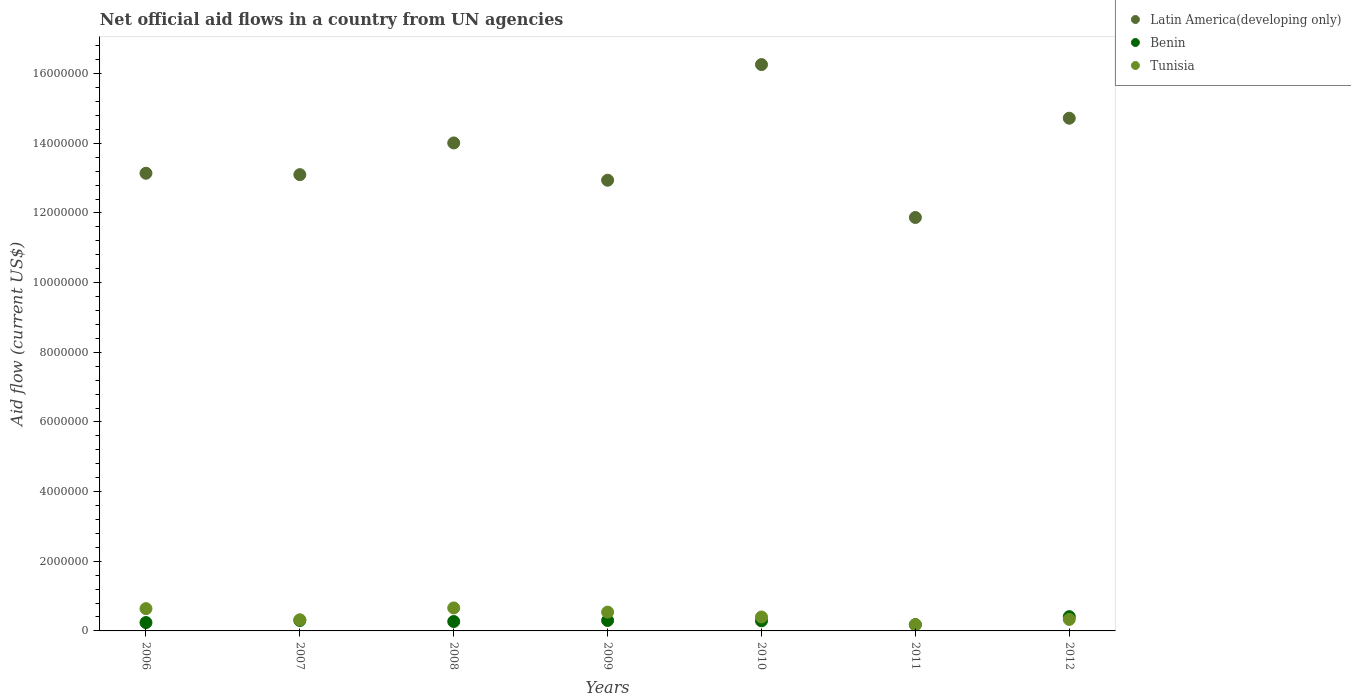Is the number of dotlines equal to the number of legend labels?
Ensure brevity in your answer.  Yes. What is the net official aid flow in Tunisia in 2008?
Ensure brevity in your answer.  6.60e+05. Across all years, what is the maximum net official aid flow in Benin?
Offer a very short reply. 4.10e+05. Across all years, what is the minimum net official aid flow in Tunisia?
Your answer should be very brief. 1.80e+05. In which year was the net official aid flow in Tunisia minimum?
Give a very brief answer. 2011. What is the total net official aid flow in Tunisia in the graph?
Your response must be concise. 3.07e+06. What is the difference between the net official aid flow in Tunisia in 2008 and that in 2010?
Make the answer very short. 2.60e+05. What is the difference between the net official aid flow in Latin America(developing only) in 2009 and the net official aid flow in Benin in 2008?
Ensure brevity in your answer.  1.27e+07. What is the average net official aid flow in Latin America(developing only) per year?
Your response must be concise. 1.37e+07. In the year 2006, what is the difference between the net official aid flow in Latin America(developing only) and net official aid flow in Tunisia?
Provide a short and direct response. 1.25e+07. What is the ratio of the net official aid flow in Benin in 2010 to that in 2012?
Your answer should be very brief. 0.71. Is the net official aid flow in Latin America(developing only) in 2006 less than that in 2007?
Your answer should be compact. No. What is the difference between the highest and the second highest net official aid flow in Latin America(developing only)?
Make the answer very short. 1.54e+06. What is the difference between the highest and the lowest net official aid flow in Benin?
Provide a short and direct response. 2.30e+05. Is it the case that in every year, the sum of the net official aid flow in Latin America(developing only) and net official aid flow in Tunisia  is greater than the net official aid flow in Benin?
Provide a short and direct response. Yes. Does the net official aid flow in Latin America(developing only) monotonically increase over the years?
Make the answer very short. No. How many years are there in the graph?
Your answer should be very brief. 7. Are the values on the major ticks of Y-axis written in scientific E-notation?
Make the answer very short. No. Does the graph contain any zero values?
Provide a succinct answer. No. Does the graph contain grids?
Ensure brevity in your answer.  No. Where does the legend appear in the graph?
Provide a succinct answer. Top right. How many legend labels are there?
Provide a short and direct response. 3. How are the legend labels stacked?
Your answer should be compact. Vertical. What is the title of the graph?
Ensure brevity in your answer.  Net official aid flows in a country from UN agencies. Does "Upper middle income" appear as one of the legend labels in the graph?
Give a very brief answer. No. What is the Aid flow (current US$) of Latin America(developing only) in 2006?
Keep it short and to the point. 1.31e+07. What is the Aid flow (current US$) of Tunisia in 2006?
Offer a very short reply. 6.40e+05. What is the Aid flow (current US$) of Latin America(developing only) in 2007?
Keep it short and to the point. 1.31e+07. What is the Aid flow (current US$) of Latin America(developing only) in 2008?
Make the answer very short. 1.40e+07. What is the Aid flow (current US$) of Latin America(developing only) in 2009?
Keep it short and to the point. 1.29e+07. What is the Aid flow (current US$) of Tunisia in 2009?
Your response must be concise. 5.40e+05. What is the Aid flow (current US$) of Latin America(developing only) in 2010?
Your response must be concise. 1.63e+07. What is the Aid flow (current US$) of Latin America(developing only) in 2011?
Give a very brief answer. 1.19e+07. What is the Aid flow (current US$) of Benin in 2011?
Keep it short and to the point. 1.80e+05. What is the Aid flow (current US$) in Tunisia in 2011?
Keep it short and to the point. 1.80e+05. What is the Aid flow (current US$) in Latin America(developing only) in 2012?
Ensure brevity in your answer.  1.47e+07. Across all years, what is the maximum Aid flow (current US$) in Latin America(developing only)?
Provide a short and direct response. 1.63e+07. Across all years, what is the maximum Aid flow (current US$) in Tunisia?
Provide a succinct answer. 6.60e+05. Across all years, what is the minimum Aid flow (current US$) of Latin America(developing only)?
Your answer should be compact. 1.19e+07. What is the total Aid flow (current US$) of Latin America(developing only) in the graph?
Your response must be concise. 9.60e+07. What is the total Aid flow (current US$) in Benin in the graph?
Your answer should be compact. 1.99e+06. What is the total Aid flow (current US$) of Tunisia in the graph?
Give a very brief answer. 3.07e+06. What is the difference between the Aid flow (current US$) in Latin America(developing only) in 2006 and that in 2007?
Your answer should be compact. 4.00e+04. What is the difference between the Aid flow (current US$) in Benin in 2006 and that in 2007?
Your answer should be very brief. -6.00e+04. What is the difference between the Aid flow (current US$) of Tunisia in 2006 and that in 2007?
Ensure brevity in your answer.  3.20e+05. What is the difference between the Aid flow (current US$) in Latin America(developing only) in 2006 and that in 2008?
Your answer should be compact. -8.70e+05. What is the difference between the Aid flow (current US$) of Benin in 2006 and that in 2008?
Your response must be concise. -3.00e+04. What is the difference between the Aid flow (current US$) in Tunisia in 2006 and that in 2008?
Give a very brief answer. -2.00e+04. What is the difference between the Aid flow (current US$) in Latin America(developing only) in 2006 and that in 2009?
Give a very brief answer. 2.00e+05. What is the difference between the Aid flow (current US$) in Tunisia in 2006 and that in 2009?
Offer a terse response. 1.00e+05. What is the difference between the Aid flow (current US$) in Latin America(developing only) in 2006 and that in 2010?
Offer a very short reply. -3.12e+06. What is the difference between the Aid flow (current US$) of Tunisia in 2006 and that in 2010?
Your response must be concise. 2.40e+05. What is the difference between the Aid flow (current US$) of Latin America(developing only) in 2006 and that in 2011?
Offer a terse response. 1.27e+06. What is the difference between the Aid flow (current US$) in Benin in 2006 and that in 2011?
Give a very brief answer. 6.00e+04. What is the difference between the Aid flow (current US$) in Tunisia in 2006 and that in 2011?
Your response must be concise. 4.60e+05. What is the difference between the Aid flow (current US$) in Latin America(developing only) in 2006 and that in 2012?
Provide a succinct answer. -1.58e+06. What is the difference between the Aid flow (current US$) of Tunisia in 2006 and that in 2012?
Ensure brevity in your answer.  3.10e+05. What is the difference between the Aid flow (current US$) of Latin America(developing only) in 2007 and that in 2008?
Your response must be concise. -9.10e+05. What is the difference between the Aid flow (current US$) of Benin in 2007 and that in 2008?
Make the answer very short. 3.00e+04. What is the difference between the Aid flow (current US$) in Tunisia in 2007 and that in 2008?
Provide a short and direct response. -3.40e+05. What is the difference between the Aid flow (current US$) of Benin in 2007 and that in 2009?
Your response must be concise. 0. What is the difference between the Aid flow (current US$) of Latin America(developing only) in 2007 and that in 2010?
Provide a succinct answer. -3.16e+06. What is the difference between the Aid flow (current US$) in Benin in 2007 and that in 2010?
Keep it short and to the point. 10000. What is the difference between the Aid flow (current US$) in Tunisia in 2007 and that in 2010?
Your answer should be compact. -8.00e+04. What is the difference between the Aid flow (current US$) of Latin America(developing only) in 2007 and that in 2011?
Your answer should be compact. 1.23e+06. What is the difference between the Aid flow (current US$) of Benin in 2007 and that in 2011?
Your response must be concise. 1.20e+05. What is the difference between the Aid flow (current US$) in Latin America(developing only) in 2007 and that in 2012?
Offer a terse response. -1.62e+06. What is the difference between the Aid flow (current US$) of Benin in 2007 and that in 2012?
Your answer should be compact. -1.10e+05. What is the difference between the Aid flow (current US$) in Tunisia in 2007 and that in 2012?
Offer a very short reply. -10000. What is the difference between the Aid flow (current US$) of Latin America(developing only) in 2008 and that in 2009?
Ensure brevity in your answer.  1.07e+06. What is the difference between the Aid flow (current US$) in Benin in 2008 and that in 2009?
Provide a short and direct response. -3.00e+04. What is the difference between the Aid flow (current US$) of Latin America(developing only) in 2008 and that in 2010?
Your answer should be compact. -2.25e+06. What is the difference between the Aid flow (current US$) of Benin in 2008 and that in 2010?
Your answer should be compact. -2.00e+04. What is the difference between the Aid flow (current US$) in Tunisia in 2008 and that in 2010?
Offer a terse response. 2.60e+05. What is the difference between the Aid flow (current US$) in Latin America(developing only) in 2008 and that in 2011?
Your answer should be compact. 2.14e+06. What is the difference between the Aid flow (current US$) of Benin in 2008 and that in 2011?
Offer a terse response. 9.00e+04. What is the difference between the Aid flow (current US$) in Latin America(developing only) in 2008 and that in 2012?
Your answer should be compact. -7.10e+05. What is the difference between the Aid flow (current US$) of Tunisia in 2008 and that in 2012?
Your answer should be compact. 3.30e+05. What is the difference between the Aid flow (current US$) of Latin America(developing only) in 2009 and that in 2010?
Offer a very short reply. -3.32e+06. What is the difference between the Aid flow (current US$) of Latin America(developing only) in 2009 and that in 2011?
Ensure brevity in your answer.  1.07e+06. What is the difference between the Aid flow (current US$) of Benin in 2009 and that in 2011?
Ensure brevity in your answer.  1.20e+05. What is the difference between the Aid flow (current US$) of Latin America(developing only) in 2009 and that in 2012?
Your answer should be compact. -1.78e+06. What is the difference between the Aid flow (current US$) of Tunisia in 2009 and that in 2012?
Your response must be concise. 2.10e+05. What is the difference between the Aid flow (current US$) in Latin America(developing only) in 2010 and that in 2011?
Offer a very short reply. 4.39e+06. What is the difference between the Aid flow (current US$) in Benin in 2010 and that in 2011?
Provide a succinct answer. 1.10e+05. What is the difference between the Aid flow (current US$) of Latin America(developing only) in 2010 and that in 2012?
Offer a very short reply. 1.54e+06. What is the difference between the Aid flow (current US$) of Latin America(developing only) in 2011 and that in 2012?
Give a very brief answer. -2.85e+06. What is the difference between the Aid flow (current US$) in Benin in 2011 and that in 2012?
Give a very brief answer. -2.30e+05. What is the difference between the Aid flow (current US$) of Tunisia in 2011 and that in 2012?
Keep it short and to the point. -1.50e+05. What is the difference between the Aid flow (current US$) in Latin America(developing only) in 2006 and the Aid flow (current US$) in Benin in 2007?
Ensure brevity in your answer.  1.28e+07. What is the difference between the Aid flow (current US$) in Latin America(developing only) in 2006 and the Aid flow (current US$) in Tunisia in 2007?
Offer a very short reply. 1.28e+07. What is the difference between the Aid flow (current US$) of Benin in 2006 and the Aid flow (current US$) of Tunisia in 2007?
Your answer should be compact. -8.00e+04. What is the difference between the Aid flow (current US$) in Latin America(developing only) in 2006 and the Aid flow (current US$) in Benin in 2008?
Offer a very short reply. 1.29e+07. What is the difference between the Aid flow (current US$) of Latin America(developing only) in 2006 and the Aid flow (current US$) of Tunisia in 2008?
Give a very brief answer. 1.25e+07. What is the difference between the Aid flow (current US$) of Benin in 2006 and the Aid flow (current US$) of Tunisia in 2008?
Provide a succinct answer. -4.20e+05. What is the difference between the Aid flow (current US$) in Latin America(developing only) in 2006 and the Aid flow (current US$) in Benin in 2009?
Your answer should be compact. 1.28e+07. What is the difference between the Aid flow (current US$) in Latin America(developing only) in 2006 and the Aid flow (current US$) in Tunisia in 2009?
Make the answer very short. 1.26e+07. What is the difference between the Aid flow (current US$) in Latin America(developing only) in 2006 and the Aid flow (current US$) in Benin in 2010?
Offer a very short reply. 1.28e+07. What is the difference between the Aid flow (current US$) of Latin America(developing only) in 2006 and the Aid flow (current US$) of Tunisia in 2010?
Your answer should be compact. 1.27e+07. What is the difference between the Aid flow (current US$) in Benin in 2006 and the Aid flow (current US$) in Tunisia in 2010?
Make the answer very short. -1.60e+05. What is the difference between the Aid flow (current US$) of Latin America(developing only) in 2006 and the Aid flow (current US$) of Benin in 2011?
Ensure brevity in your answer.  1.30e+07. What is the difference between the Aid flow (current US$) of Latin America(developing only) in 2006 and the Aid flow (current US$) of Tunisia in 2011?
Provide a succinct answer. 1.30e+07. What is the difference between the Aid flow (current US$) of Benin in 2006 and the Aid flow (current US$) of Tunisia in 2011?
Your answer should be compact. 6.00e+04. What is the difference between the Aid flow (current US$) in Latin America(developing only) in 2006 and the Aid flow (current US$) in Benin in 2012?
Provide a succinct answer. 1.27e+07. What is the difference between the Aid flow (current US$) of Latin America(developing only) in 2006 and the Aid flow (current US$) of Tunisia in 2012?
Ensure brevity in your answer.  1.28e+07. What is the difference between the Aid flow (current US$) of Latin America(developing only) in 2007 and the Aid flow (current US$) of Benin in 2008?
Offer a very short reply. 1.28e+07. What is the difference between the Aid flow (current US$) in Latin America(developing only) in 2007 and the Aid flow (current US$) in Tunisia in 2008?
Offer a very short reply. 1.24e+07. What is the difference between the Aid flow (current US$) in Benin in 2007 and the Aid flow (current US$) in Tunisia in 2008?
Make the answer very short. -3.60e+05. What is the difference between the Aid flow (current US$) of Latin America(developing only) in 2007 and the Aid flow (current US$) of Benin in 2009?
Your answer should be very brief. 1.28e+07. What is the difference between the Aid flow (current US$) in Latin America(developing only) in 2007 and the Aid flow (current US$) in Tunisia in 2009?
Your response must be concise. 1.26e+07. What is the difference between the Aid flow (current US$) of Latin America(developing only) in 2007 and the Aid flow (current US$) of Benin in 2010?
Make the answer very short. 1.28e+07. What is the difference between the Aid flow (current US$) in Latin America(developing only) in 2007 and the Aid flow (current US$) in Tunisia in 2010?
Keep it short and to the point. 1.27e+07. What is the difference between the Aid flow (current US$) of Benin in 2007 and the Aid flow (current US$) of Tunisia in 2010?
Your response must be concise. -1.00e+05. What is the difference between the Aid flow (current US$) in Latin America(developing only) in 2007 and the Aid flow (current US$) in Benin in 2011?
Your answer should be compact. 1.29e+07. What is the difference between the Aid flow (current US$) of Latin America(developing only) in 2007 and the Aid flow (current US$) of Tunisia in 2011?
Offer a very short reply. 1.29e+07. What is the difference between the Aid flow (current US$) of Latin America(developing only) in 2007 and the Aid flow (current US$) of Benin in 2012?
Provide a succinct answer. 1.27e+07. What is the difference between the Aid flow (current US$) of Latin America(developing only) in 2007 and the Aid flow (current US$) of Tunisia in 2012?
Offer a very short reply. 1.28e+07. What is the difference between the Aid flow (current US$) of Benin in 2007 and the Aid flow (current US$) of Tunisia in 2012?
Keep it short and to the point. -3.00e+04. What is the difference between the Aid flow (current US$) of Latin America(developing only) in 2008 and the Aid flow (current US$) of Benin in 2009?
Your answer should be very brief. 1.37e+07. What is the difference between the Aid flow (current US$) of Latin America(developing only) in 2008 and the Aid flow (current US$) of Tunisia in 2009?
Your response must be concise. 1.35e+07. What is the difference between the Aid flow (current US$) of Benin in 2008 and the Aid flow (current US$) of Tunisia in 2009?
Keep it short and to the point. -2.70e+05. What is the difference between the Aid flow (current US$) of Latin America(developing only) in 2008 and the Aid flow (current US$) of Benin in 2010?
Provide a short and direct response. 1.37e+07. What is the difference between the Aid flow (current US$) of Latin America(developing only) in 2008 and the Aid flow (current US$) of Tunisia in 2010?
Make the answer very short. 1.36e+07. What is the difference between the Aid flow (current US$) of Latin America(developing only) in 2008 and the Aid flow (current US$) of Benin in 2011?
Your answer should be very brief. 1.38e+07. What is the difference between the Aid flow (current US$) of Latin America(developing only) in 2008 and the Aid flow (current US$) of Tunisia in 2011?
Your answer should be very brief. 1.38e+07. What is the difference between the Aid flow (current US$) of Latin America(developing only) in 2008 and the Aid flow (current US$) of Benin in 2012?
Your response must be concise. 1.36e+07. What is the difference between the Aid flow (current US$) in Latin America(developing only) in 2008 and the Aid flow (current US$) in Tunisia in 2012?
Provide a succinct answer. 1.37e+07. What is the difference between the Aid flow (current US$) of Benin in 2008 and the Aid flow (current US$) of Tunisia in 2012?
Ensure brevity in your answer.  -6.00e+04. What is the difference between the Aid flow (current US$) in Latin America(developing only) in 2009 and the Aid flow (current US$) in Benin in 2010?
Provide a short and direct response. 1.26e+07. What is the difference between the Aid flow (current US$) in Latin America(developing only) in 2009 and the Aid flow (current US$) in Tunisia in 2010?
Your response must be concise. 1.25e+07. What is the difference between the Aid flow (current US$) in Benin in 2009 and the Aid flow (current US$) in Tunisia in 2010?
Keep it short and to the point. -1.00e+05. What is the difference between the Aid flow (current US$) in Latin America(developing only) in 2009 and the Aid flow (current US$) in Benin in 2011?
Your answer should be very brief. 1.28e+07. What is the difference between the Aid flow (current US$) in Latin America(developing only) in 2009 and the Aid flow (current US$) in Tunisia in 2011?
Make the answer very short. 1.28e+07. What is the difference between the Aid flow (current US$) of Latin America(developing only) in 2009 and the Aid flow (current US$) of Benin in 2012?
Provide a succinct answer. 1.25e+07. What is the difference between the Aid flow (current US$) of Latin America(developing only) in 2009 and the Aid flow (current US$) of Tunisia in 2012?
Offer a very short reply. 1.26e+07. What is the difference between the Aid flow (current US$) of Latin America(developing only) in 2010 and the Aid flow (current US$) of Benin in 2011?
Give a very brief answer. 1.61e+07. What is the difference between the Aid flow (current US$) in Latin America(developing only) in 2010 and the Aid flow (current US$) in Tunisia in 2011?
Give a very brief answer. 1.61e+07. What is the difference between the Aid flow (current US$) in Latin America(developing only) in 2010 and the Aid flow (current US$) in Benin in 2012?
Offer a terse response. 1.58e+07. What is the difference between the Aid flow (current US$) of Latin America(developing only) in 2010 and the Aid flow (current US$) of Tunisia in 2012?
Your response must be concise. 1.59e+07. What is the difference between the Aid flow (current US$) in Benin in 2010 and the Aid flow (current US$) in Tunisia in 2012?
Offer a very short reply. -4.00e+04. What is the difference between the Aid flow (current US$) in Latin America(developing only) in 2011 and the Aid flow (current US$) in Benin in 2012?
Give a very brief answer. 1.15e+07. What is the difference between the Aid flow (current US$) of Latin America(developing only) in 2011 and the Aid flow (current US$) of Tunisia in 2012?
Provide a short and direct response. 1.15e+07. What is the average Aid flow (current US$) in Latin America(developing only) per year?
Ensure brevity in your answer.  1.37e+07. What is the average Aid flow (current US$) of Benin per year?
Offer a very short reply. 2.84e+05. What is the average Aid flow (current US$) in Tunisia per year?
Provide a short and direct response. 4.39e+05. In the year 2006, what is the difference between the Aid flow (current US$) in Latin America(developing only) and Aid flow (current US$) in Benin?
Your response must be concise. 1.29e+07. In the year 2006, what is the difference between the Aid flow (current US$) in Latin America(developing only) and Aid flow (current US$) in Tunisia?
Your response must be concise. 1.25e+07. In the year 2006, what is the difference between the Aid flow (current US$) of Benin and Aid flow (current US$) of Tunisia?
Provide a short and direct response. -4.00e+05. In the year 2007, what is the difference between the Aid flow (current US$) in Latin America(developing only) and Aid flow (current US$) in Benin?
Provide a succinct answer. 1.28e+07. In the year 2007, what is the difference between the Aid flow (current US$) in Latin America(developing only) and Aid flow (current US$) in Tunisia?
Your response must be concise. 1.28e+07. In the year 2008, what is the difference between the Aid flow (current US$) of Latin America(developing only) and Aid flow (current US$) of Benin?
Keep it short and to the point. 1.37e+07. In the year 2008, what is the difference between the Aid flow (current US$) in Latin America(developing only) and Aid flow (current US$) in Tunisia?
Keep it short and to the point. 1.34e+07. In the year 2008, what is the difference between the Aid flow (current US$) in Benin and Aid flow (current US$) in Tunisia?
Give a very brief answer. -3.90e+05. In the year 2009, what is the difference between the Aid flow (current US$) of Latin America(developing only) and Aid flow (current US$) of Benin?
Keep it short and to the point. 1.26e+07. In the year 2009, what is the difference between the Aid flow (current US$) in Latin America(developing only) and Aid flow (current US$) in Tunisia?
Ensure brevity in your answer.  1.24e+07. In the year 2009, what is the difference between the Aid flow (current US$) of Benin and Aid flow (current US$) of Tunisia?
Give a very brief answer. -2.40e+05. In the year 2010, what is the difference between the Aid flow (current US$) in Latin America(developing only) and Aid flow (current US$) in Benin?
Your answer should be very brief. 1.60e+07. In the year 2010, what is the difference between the Aid flow (current US$) of Latin America(developing only) and Aid flow (current US$) of Tunisia?
Provide a short and direct response. 1.59e+07. In the year 2010, what is the difference between the Aid flow (current US$) of Benin and Aid flow (current US$) of Tunisia?
Your answer should be very brief. -1.10e+05. In the year 2011, what is the difference between the Aid flow (current US$) in Latin America(developing only) and Aid flow (current US$) in Benin?
Give a very brief answer. 1.17e+07. In the year 2011, what is the difference between the Aid flow (current US$) of Latin America(developing only) and Aid flow (current US$) of Tunisia?
Keep it short and to the point. 1.17e+07. In the year 2012, what is the difference between the Aid flow (current US$) in Latin America(developing only) and Aid flow (current US$) in Benin?
Your response must be concise. 1.43e+07. In the year 2012, what is the difference between the Aid flow (current US$) in Latin America(developing only) and Aid flow (current US$) in Tunisia?
Keep it short and to the point. 1.44e+07. In the year 2012, what is the difference between the Aid flow (current US$) in Benin and Aid flow (current US$) in Tunisia?
Your answer should be very brief. 8.00e+04. What is the ratio of the Aid flow (current US$) in Tunisia in 2006 to that in 2007?
Offer a very short reply. 2. What is the ratio of the Aid flow (current US$) in Latin America(developing only) in 2006 to that in 2008?
Offer a very short reply. 0.94. What is the ratio of the Aid flow (current US$) of Tunisia in 2006 to that in 2008?
Offer a very short reply. 0.97. What is the ratio of the Aid flow (current US$) in Latin America(developing only) in 2006 to that in 2009?
Your answer should be very brief. 1.02. What is the ratio of the Aid flow (current US$) in Benin in 2006 to that in 2009?
Your answer should be very brief. 0.8. What is the ratio of the Aid flow (current US$) in Tunisia in 2006 to that in 2009?
Provide a short and direct response. 1.19. What is the ratio of the Aid flow (current US$) of Latin America(developing only) in 2006 to that in 2010?
Your answer should be very brief. 0.81. What is the ratio of the Aid flow (current US$) in Benin in 2006 to that in 2010?
Give a very brief answer. 0.83. What is the ratio of the Aid flow (current US$) in Tunisia in 2006 to that in 2010?
Your response must be concise. 1.6. What is the ratio of the Aid flow (current US$) in Latin America(developing only) in 2006 to that in 2011?
Offer a terse response. 1.11. What is the ratio of the Aid flow (current US$) of Benin in 2006 to that in 2011?
Offer a very short reply. 1.33. What is the ratio of the Aid flow (current US$) in Tunisia in 2006 to that in 2011?
Offer a terse response. 3.56. What is the ratio of the Aid flow (current US$) of Latin America(developing only) in 2006 to that in 2012?
Offer a terse response. 0.89. What is the ratio of the Aid flow (current US$) of Benin in 2006 to that in 2012?
Offer a very short reply. 0.59. What is the ratio of the Aid flow (current US$) of Tunisia in 2006 to that in 2012?
Your answer should be very brief. 1.94. What is the ratio of the Aid flow (current US$) of Latin America(developing only) in 2007 to that in 2008?
Keep it short and to the point. 0.94. What is the ratio of the Aid flow (current US$) of Benin in 2007 to that in 2008?
Make the answer very short. 1.11. What is the ratio of the Aid flow (current US$) in Tunisia in 2007 to that in 2008?
Your answer should be compact. 0.48. What is the ratio of the Aid flow (current US$) in Latin America(developing only) in 2007 to that in 2009?
Ensure brevity in your answer.  1.01. What is the ratio of the Aid flow (current US$) of Tunisia in 2007 to that in 2009?
Offer a terse response. 0.59. What is the ratio of the Aid flow (current US$) of Latin America(developing only) in 2007 to that in 2010?
Give a very brief answer. 0.81. What is the ratio of the Aid flow (current US$) in Benin in 2007 to that in 2010?
Your answer should be very brief. 1.03. What is the ratio of the Aid flow (current US$) in Latin America(developing only) in 2007 to that in 2011?
Provide a succinct answer. 1.1. What is the ratio of the Aid flow (current US$) of Tunisia in 2007 to that in 2011?
Keep it short and to the point. 1.78. What is the ratio of the Aid flow (current US$) in Latin America(developing only) in 2007 to that in 2012?
Your answer should be very brief. 0.89. What is the ratio of the Aid flow (current US$) of Benin in 2007 to that in 2012?
Provide a short and direct response. 0.73. What is the ratio of the Aid flow (current US$) in Tunisia in 2007 to that in 2012?
Give a very brief answer. 0.97. What is the ratio of the Aid flow (current US$) in Latin America(developing only) in 2008 to that in 2009?
Ensure brevity in your answer.  1.08. What is the ratio of the Aid flow (current US$) of Tunisia in 2008 to that in 2009?
Offer a terse response. 1.22. What is the ratio of the Aid flow (current US$) in Latin America(developing only) in 2008 to that in 2010?
Ensure brevity in your answer.  0.86. What is the ratio of the Aid flow (current US$) of Benin in 2008 to that in 2010?
Ensure brevity in your answer.  0.93. What is the ratio of the Aid flow (current US$) in Tunisia in 2008 to that in 2010?
Your response must be concise. 1.65. What is the ratio of the Aid flow (current US$) in Latin America(developing only) in 2008 to that in 2011?
Your response must be concise. 1.18. What is the ratio of the Aid flow (current US$) in Benin in 2008 to that in 2011?
Provide a succinct answer. 1.5. What is the ratio of the Aid flow (current US$) of Tunisia in 2008 to that in 2011?
Keep it short and to the point. 3.67. What is the ratio of the Aid flow (current US$) in Latin America(developing only) in 2008 to that in 2012?
Your answer should be compact. 0.95. What is the ratio of the Aid flow (current US$) in Benin in 2008 to that in 2012?
Your answer should be very brief. 0.66. What is the ratio of the Aid flow (current US$) in Latin America(developing only) in 2009 to that in 2010?
Give a very brief answer. 0.8. What is the ratio of the Aid flow (current US$) in Benin in 2009 to that in 2010?
Your answer should be compact. 1.03. What is the ratio of the Aid flow (current US$) of Tunisia in 2009 to that in 2010?
Provide a succinct answer. 1.35. What is the ratio of the Aid flow (current US$) in Latin America(developing only) in 2009 to that in 2011?
Ensure brevity in your answer.  1.09. What is the ratio of the Aid flow (current US$) in Benin in 2009 to that in 2011?
Your answer should be very brief. 1.67. What is the ratio of the Aid flow (current US$) in Latin America(developing only) in 2009 to that in 2012?
Offer a very short reply. 0.88. What is the ratio of the Aid flow (current US$) in Benin in 2009 to that in 2012?
Offer a very short reply. 0.73. What is the ratio of the Aid flow (current US$) of Tunisia in 2009 to that in 2012?
Make the answer very short. 1.64. What is the ratio of the Aid flow (current US$) in Latin America(developing only) in 2010 to that in 2011?
Keep it short and to the point. 1.37. What is the ratio of the Aid flow (current US$) of Benin in 2010 to that in 2011?
Keep it short and to the point. 1.61. What is the ratio of the Aid flow (current US$) in Tunisia in 2010 to that in 2011?
Offer a terse response. 2.22. What is the ratio of the Aid flow (current US$) of Latin America(developing only) in 2010 to that in 2012?
Give a very brief answer. 1.1. What is the ratio of the Aid flow (current US$) of Benin in 2010 to that in 2012?
Your answer should be very brief. 0.71. What is the ratio of the Aid flow (current US$) of Tunisia in 2010 to that in 2012?
Your response must be concise. 1.21. What is the ratio of the Aid flow (current US$) of Latin America(developing only) in 2011 to that in 2012?
Your answer should be very brief. 0.81. What is the ratio of the Aid flow (current US$) of Benin in 2011 to that in 2012?
Give a very brief answer. 0.44. What is the ratio of the Aid flow (current US$) of Tunisia in 2011 to that in 2012?
Your response must be concise. 0.55. What is the difference between the highest and the second highest Aid flow (current US$) of Latin America(developing only)?
Ensure brevity in your answer.  1.54e+06. What is the difference between the highest and the second highest Aid flow (current US$) of Benin?
Your answer should be very brief. 1.10e+05. What is the difference between the highest and the second highest Aid flow (current US$) in Tunisia?
Make the answer very short. 2.00e+04. What is the difference between the highest and the lowest Aid flow (current US$) in Latin America(developing only)?
Keep it short and to the point. 4.39e+06. What is the difference between the highest and the lowest Aid flow (current US$) in Benin?
Make the answer very short. 2.30e+05. 